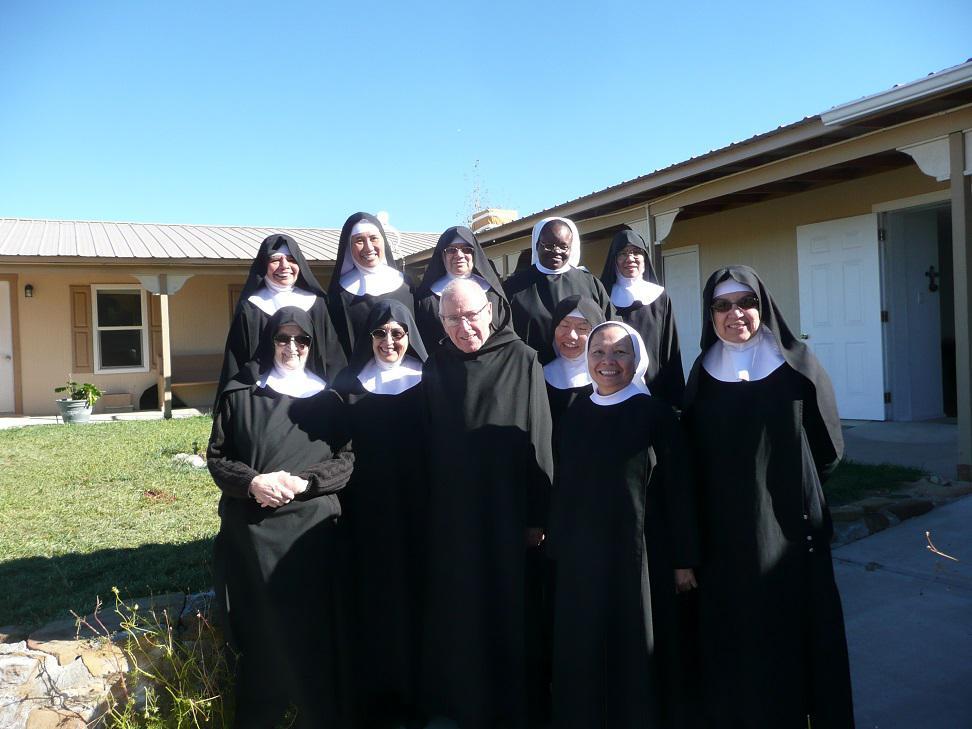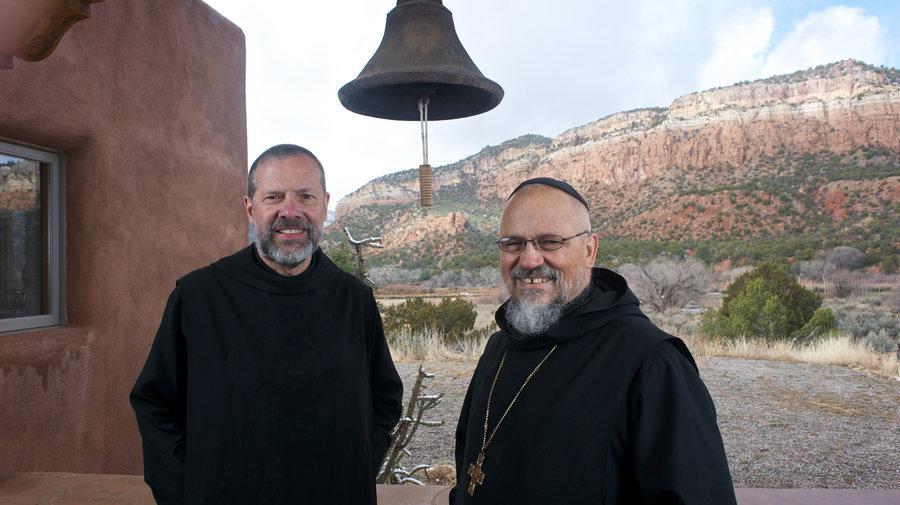The first image is the image on the left, the second image is the image on the right. Examine the images to the left and right. Is the description "At least 10 nuns are posing as a group in one of the pictures." accurate? Answer yes or no. Yes. 